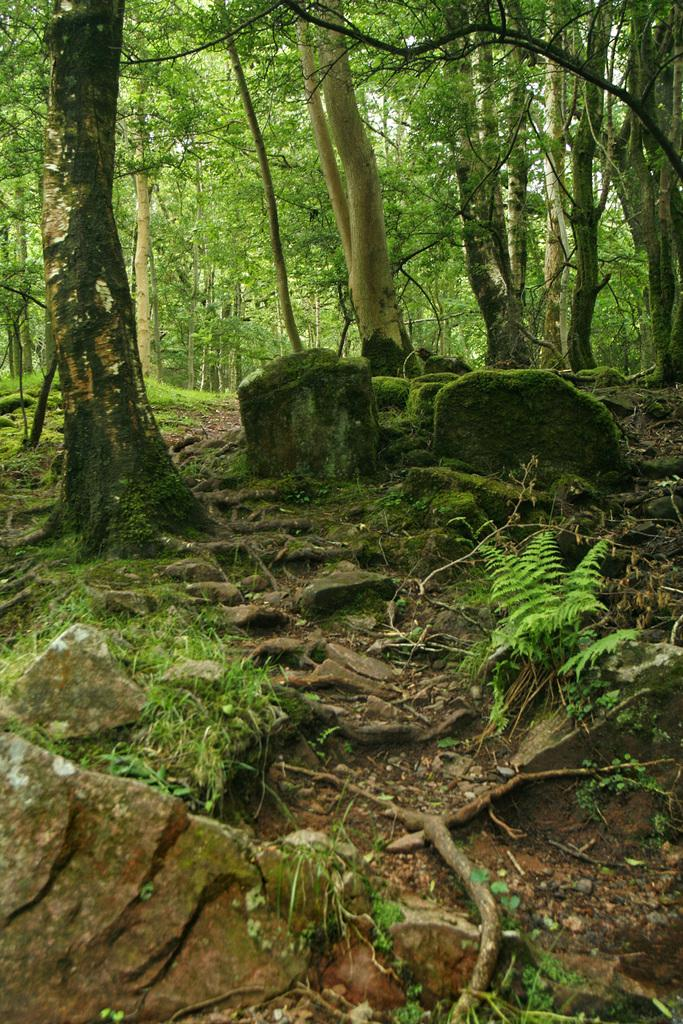What type of living organisms can be seen in the image? Plants and trees are visible in the image. What color are the plants and trees in the image? The plants and trees are green. What is visible in the background of the image? The background of the image is the sky. What color is the sky in the image? The sky is white. What type of juice is being served in the lunchroom in the image? There is no lunchroom or juice present in the image; it features plants, trees, and a white sky. 